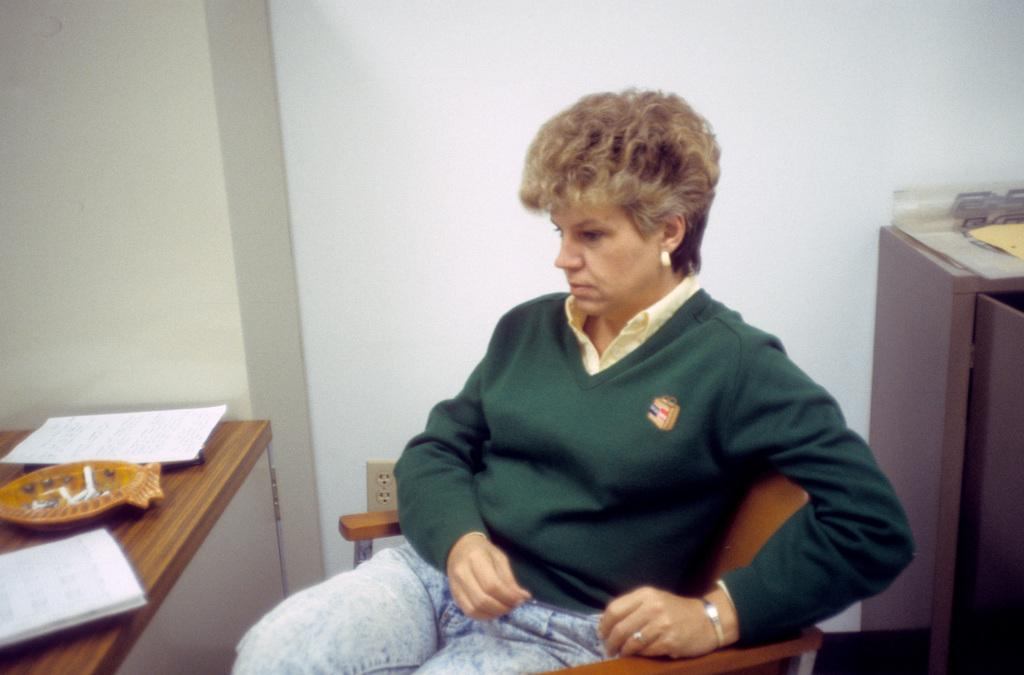What is the woman in the image doing? The woman is sitting in a chair. What is in front of the chair? There is a table in front of the chair. What is on the table? There are papers and other objects on the table. What can be seen behind the woman? There is a wall visible in the image. Can you see the woman's pet in the wilderness in the image? There is no pet or wilderness present in the image; it features a woman sitting in a chair with a table and papers in front of her. 